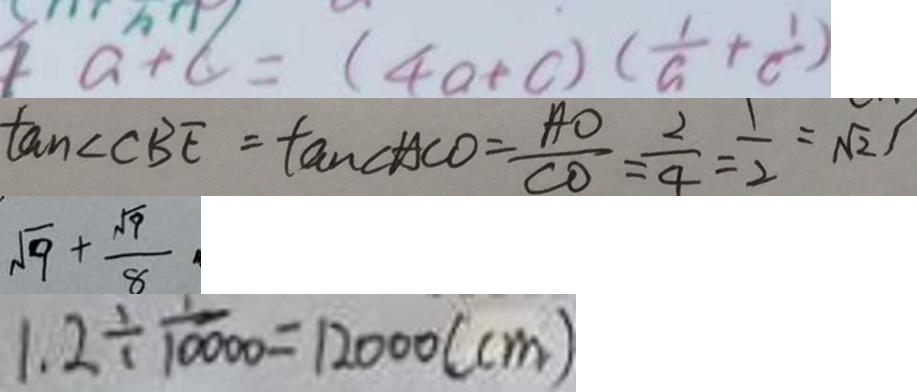<formula> <loc_0><loc_0><loc_500><loc_500>a + c = ( 4 a + c ) ( \frac { 1 } { a } + \frac { 1 } { c } ) 
 \tan \angle C B E = \tan \angle A C O = \frac { A O } { C O } = \frac { 2 } { 4 } = \frac { 1 } { 2 } = \sqrt { 2 } 
 \sqrt { 9 } + \frac { \sqrt { 9 } } { 8 } 
 1 . 2 \div \frac { 1 } { 1 0 0 0 0 } = 1 2 0 0 0 ( c m )</formula> 